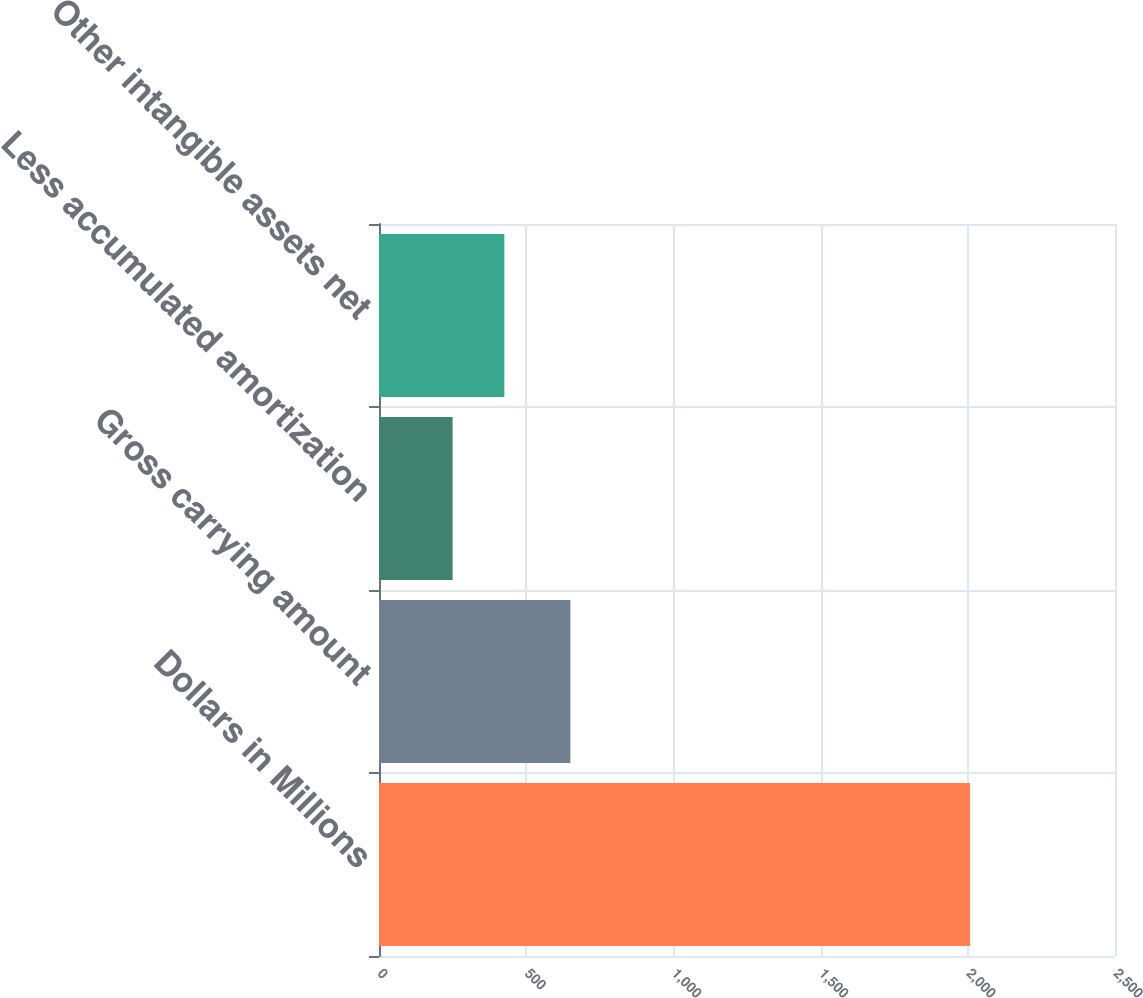<chart> <loc_0><loc_0><loc_500><loc_500><bar_chart><fcel>Dollars in Millions<fcel>Gross carrying amount<fcel>Less accumulated amortization<fcel>Other intangible assets net<nl><fcel>2008<fcel>650<fcel>250<fcel>425.8<nl></chart> 